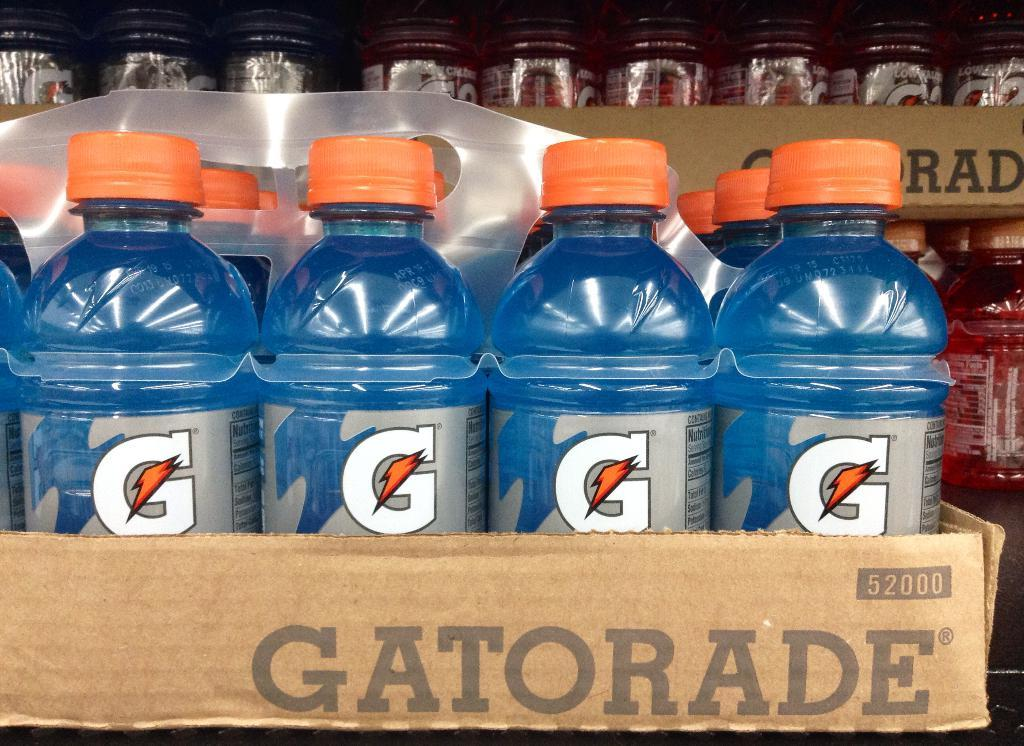Provide a one-sentence caption for the provided image. a few bottles of Gatorade that is blue in color. 